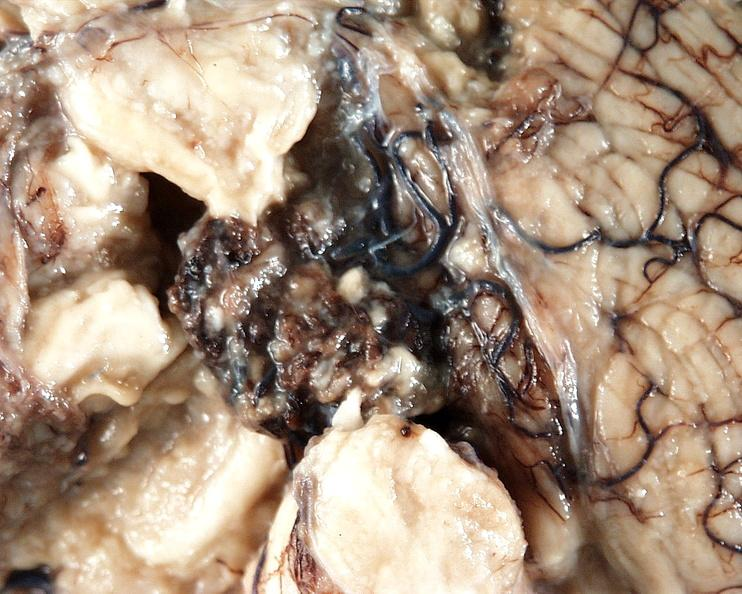what is present?
Answer the question using a single word or phrase. Nervous 